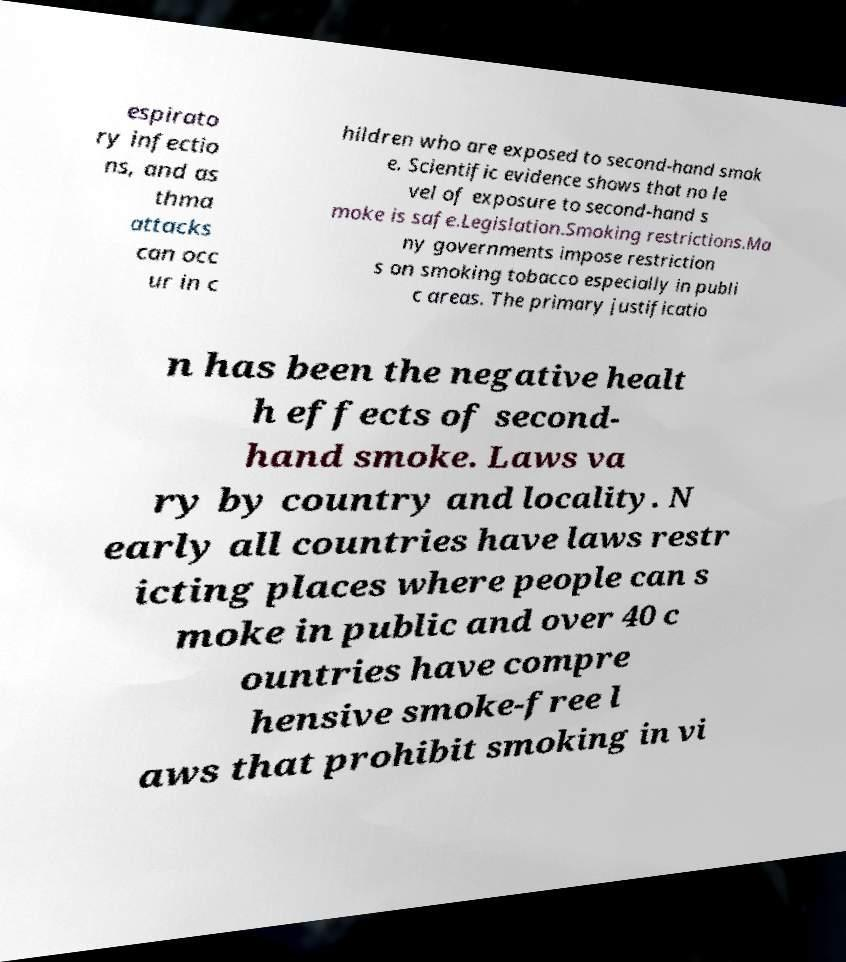Please identify and transcribe the text found in this image. espirato ry infectio ns, and as thma attacks can occ ur in c hildren who are exposed to second-hand smok e. Scientific evidence shows that no le vel of exposure to second-hand s moke is safe.Legislation.Smoking restrictions.Ma ny governments impose restriction s on smoking tobacco especially in publi c areas. The primary justificatio n has been the negative healt h effects of second- hand smoke. Laws va ry by country and locality. N early all countries have laws restr icting places where people can s moke in public and over 40 c ountries have compre hensive smoke-free l aws that prohibit smoking in vi 